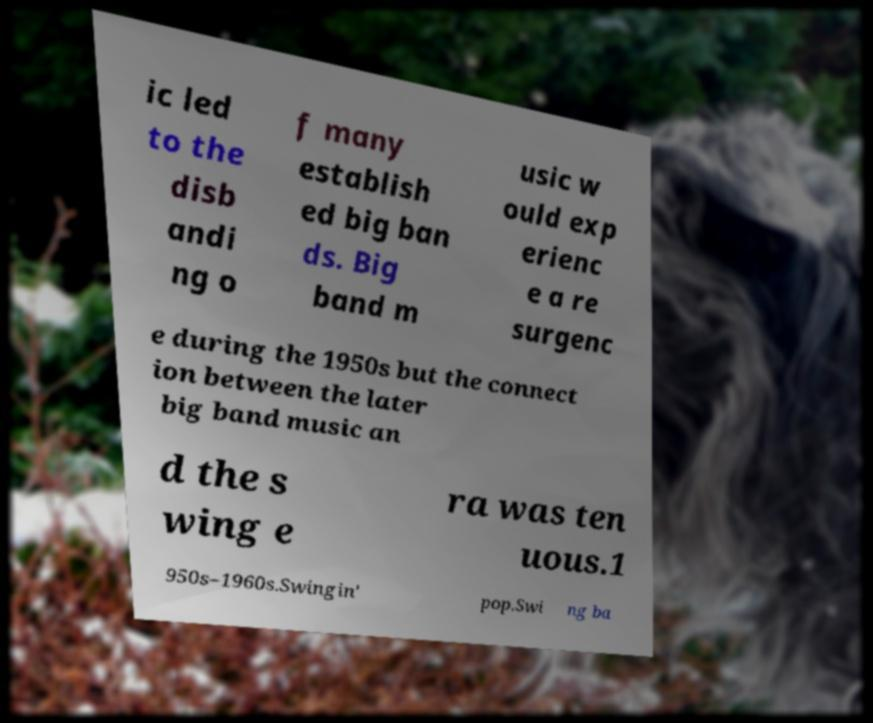I need the written content from this picture converted into text. Can you do that? ic led to the disb andi ng o f many establish ed big ban ds. Big band m usic w ould exp erienc e a re surgenc e during the 1950s but the connect ion between the later big band music an d the s wing e ra was ten uous.1 950s–1960s.Swingin' pop.Swi ng ba 